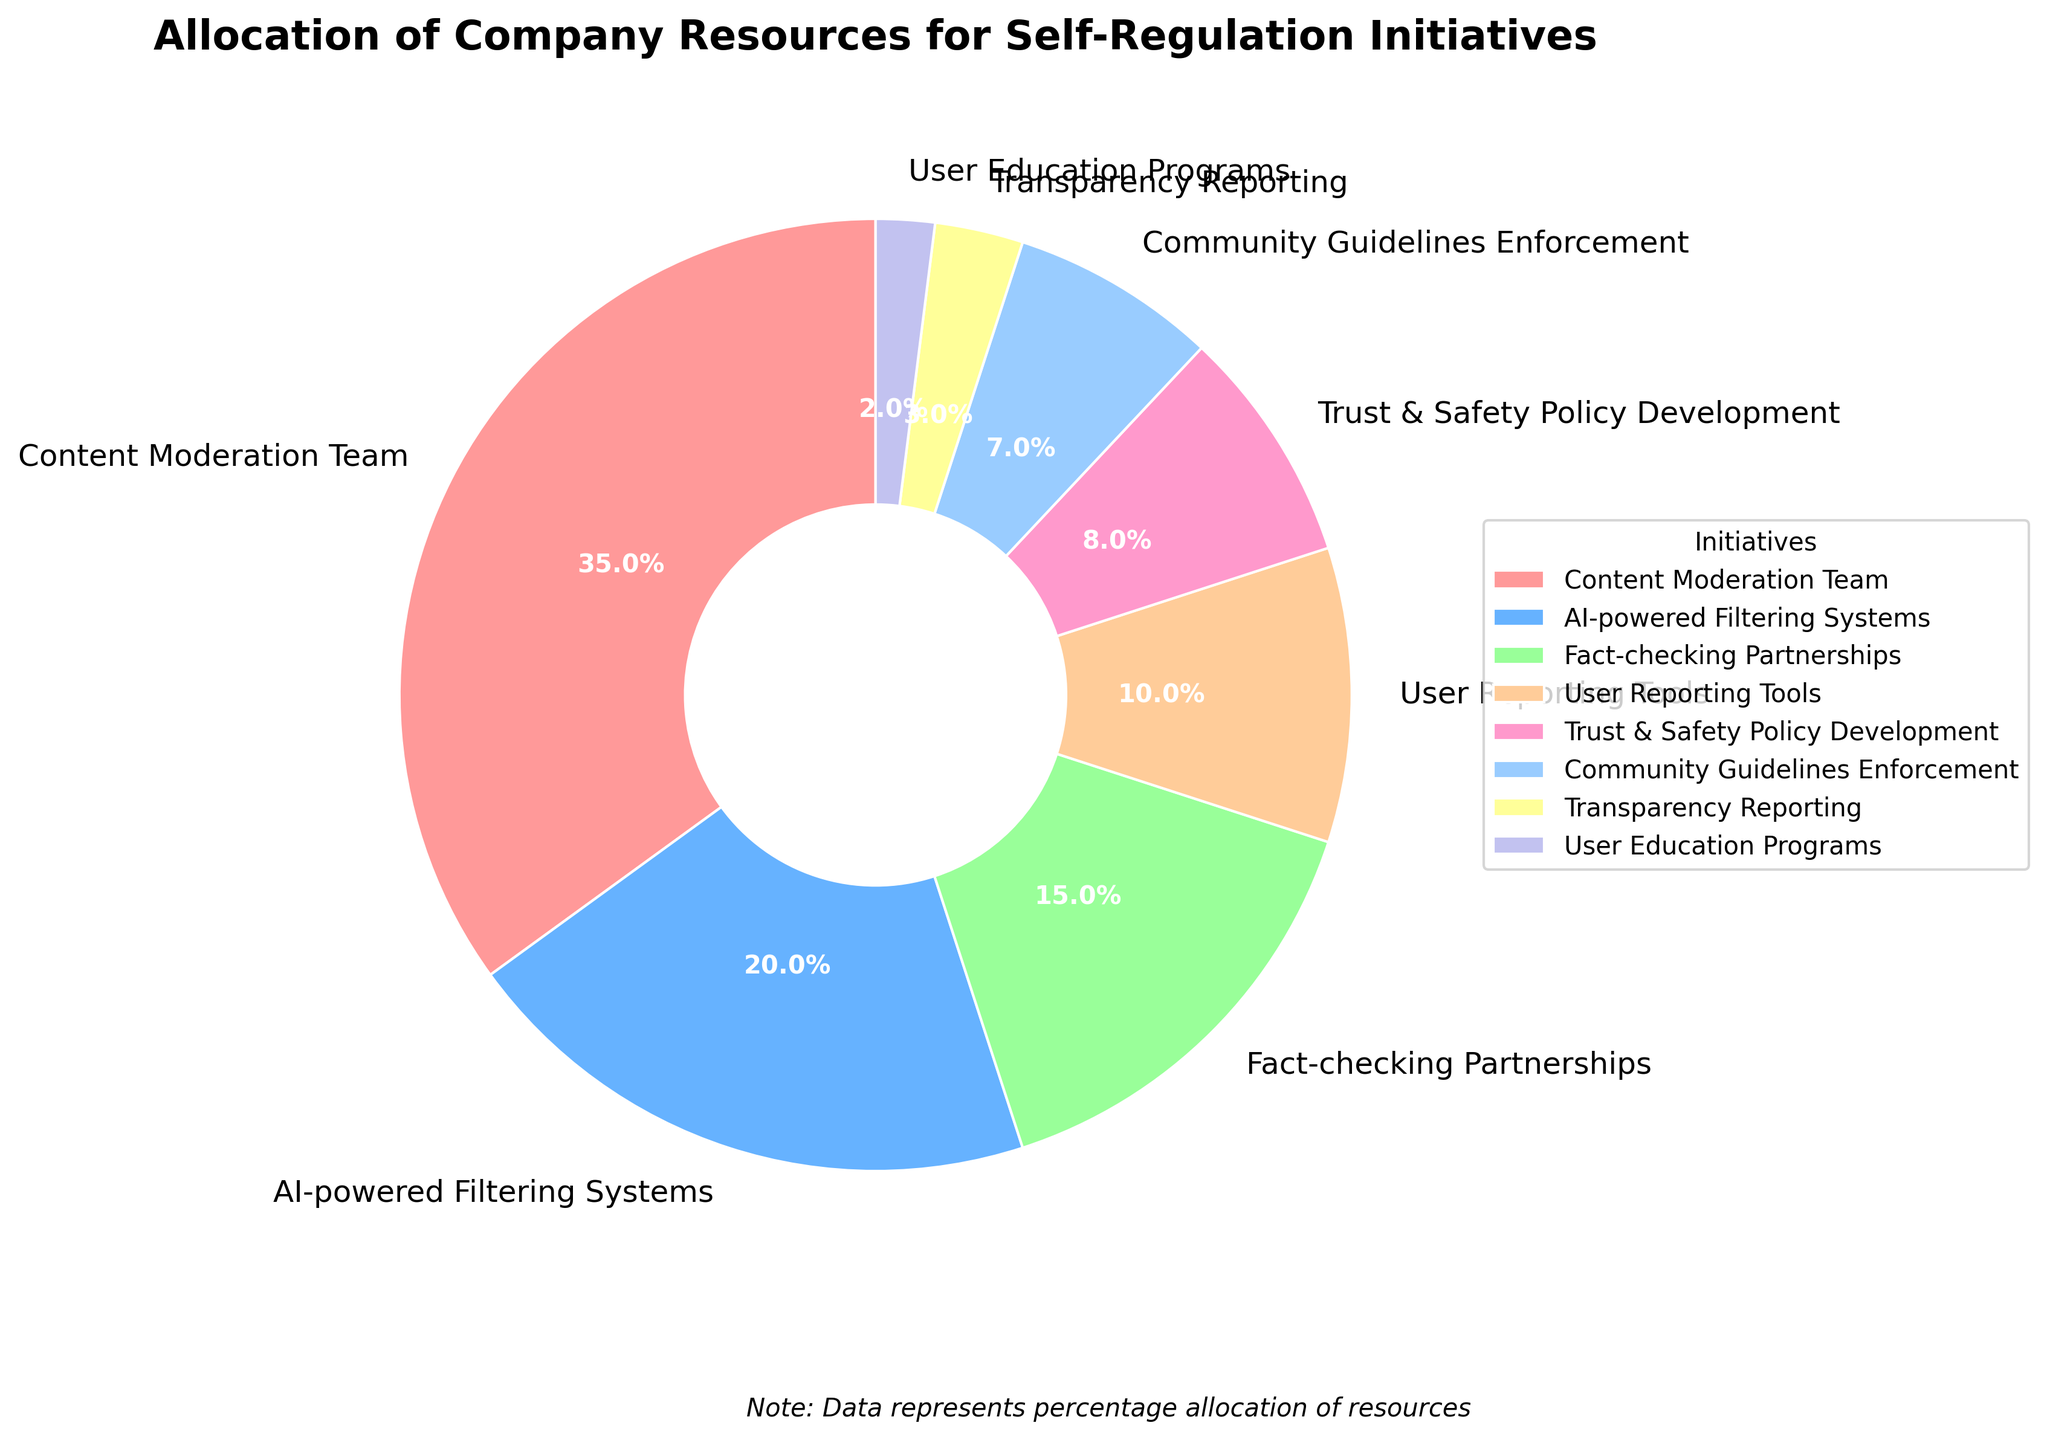What initiative has the highest allocation percentage? The figure shows that the Content Moderation Team has the largest wedge, indicating it receives the most resources.
Answer: Content Moderation Team What is the combined percentage of resources allocated to AI-powered Filtering Systems and Fact-checking Partnerships? From the chart, AI-powered Filtering Systems is allocated 20%, and Fact-checking Partnerships is allocated 15%. Adding these together: 20% + 15% = 35%.
Answer: 35% Which initiative receives more resources, User Reporting Tools or Trust & Safety Policy Development, and by how much? The chart shows User Reporting Tools has 10% and Trust & Safety Policy Development has 8%. The difference is 10% - 8% = 2%.
Answer: User Reporting Tools by 2% How much more percentage is given to AI-powered Filtering Systems compared to Community Guidelines Enforcement? The chart indicates AI-powered Filtering Systems gets 20%, while Community Guidelines Enforcement gets 7%. The difference is 20% - 7% = 13%.
Answer: 13% Which initiative has the smallest allocation of resources and what is its percentage? The chart shows that User Education Programs receives the smallest slice, which is 2%.
Answer: User Education Programs, 2% What's the difference between the highest and lowest resource allocation percentages? The highest allocation is Content Moderation Team at 35%, and the lowest is User Education Programs at 2%. The difference is 35% - 2% = 33%.
Answer: 33% What is the total percentage of resources allocated to initiatives related specifically to user interaction (User Reporting Tools and User Education Programs)? User Reporting Tools are allocated 10% and User Education Programs 2%. Adding these, we get 10% + 2% = 12%.
Answer: 12% If the resources for Transparency Reporting were doubled, would it still be the initiative with the lowest allocation? The current allocation for Transparency Reporting is 3%. Doubling it gives 3% * 2 = 6%, which is still higher than User Education Programs at 2%. Therefore, it would no longer be the lowest.
Answer: No, it wouldn't be the lowest 